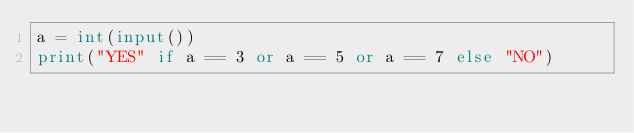Convert code to text. <code><loc_0><loc_0><loc_500><loc_500><_Python_>a = int(input())
print("YES" if a == 3 or a == 5 or a == 7 else "NO")</code> 